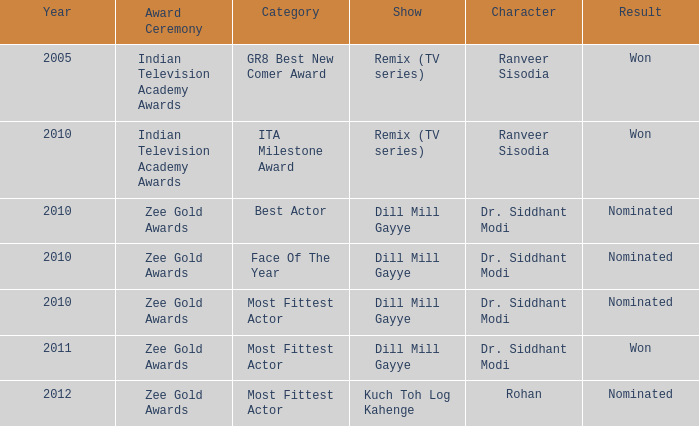Which character was nominated in the 2010 Indian Television Academy Awards? Ranveer Sisodia. 